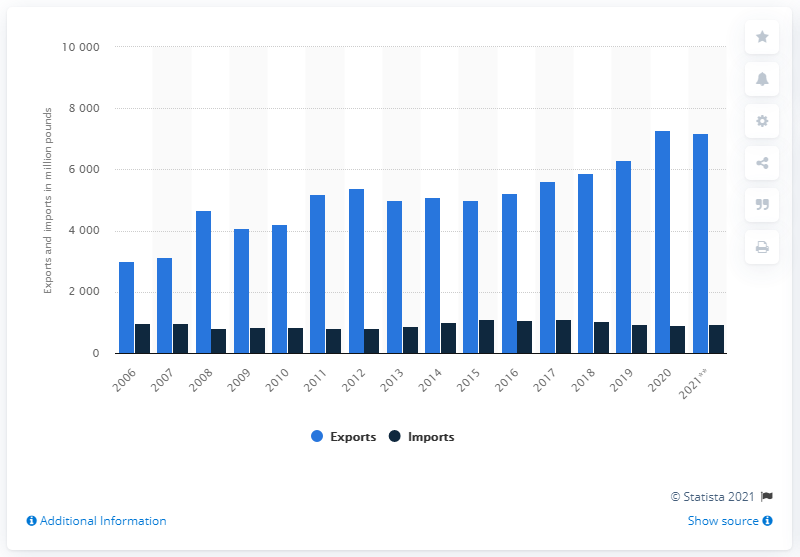Draw attention to some important aspects in this diagram. In 2020, the United States imported a significant quantity of pork, estimated to be 904 million pounds. In 2019, the United States exported 109,100 metric tons of pork, an increase from the previous year. In 2015, the United States began exporting pork. 